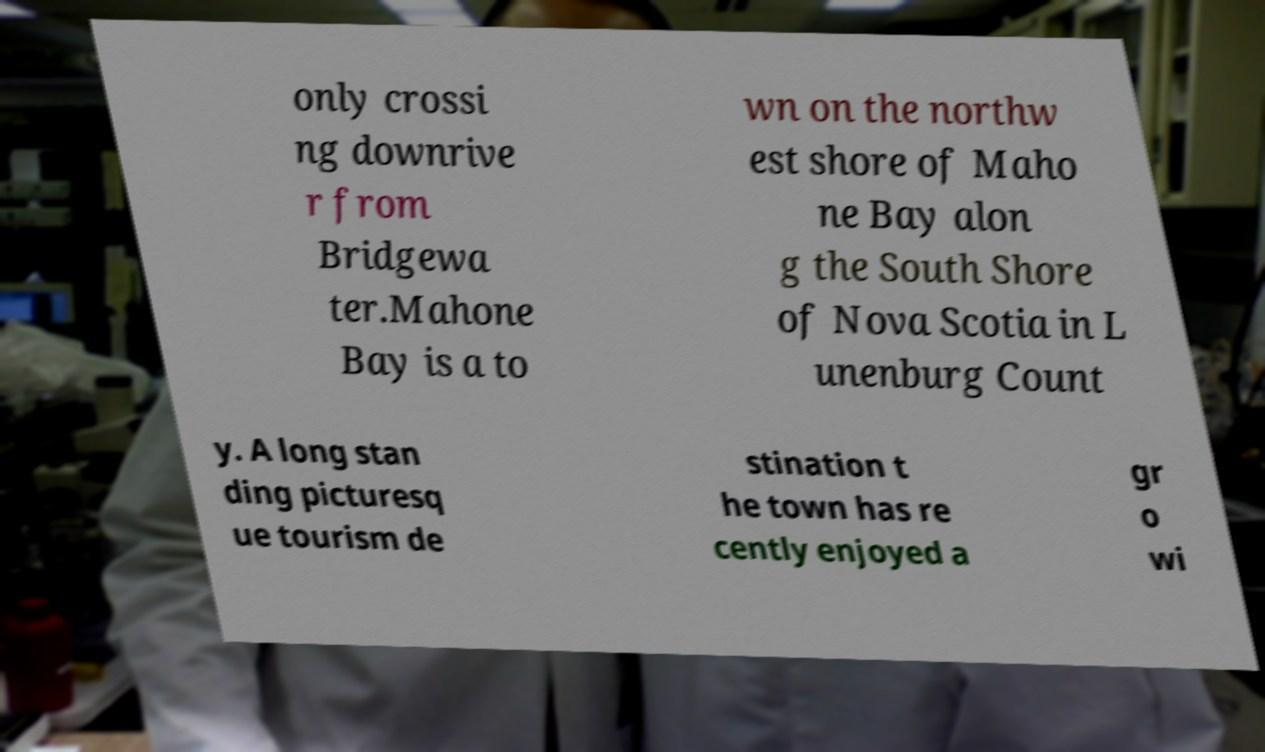Please read and relay the text visible in this image. What does it say? only crossi ng downrive r from Bridgewa ter.Mahone Bay is a to wn on the northw est shore of Maho ne Bay alon g the South Shore of Nova Scotia in L unenburg Count y. A long stan ding picturesq ue tourism de stination t he town has re cently enjoyed a gr o wi 